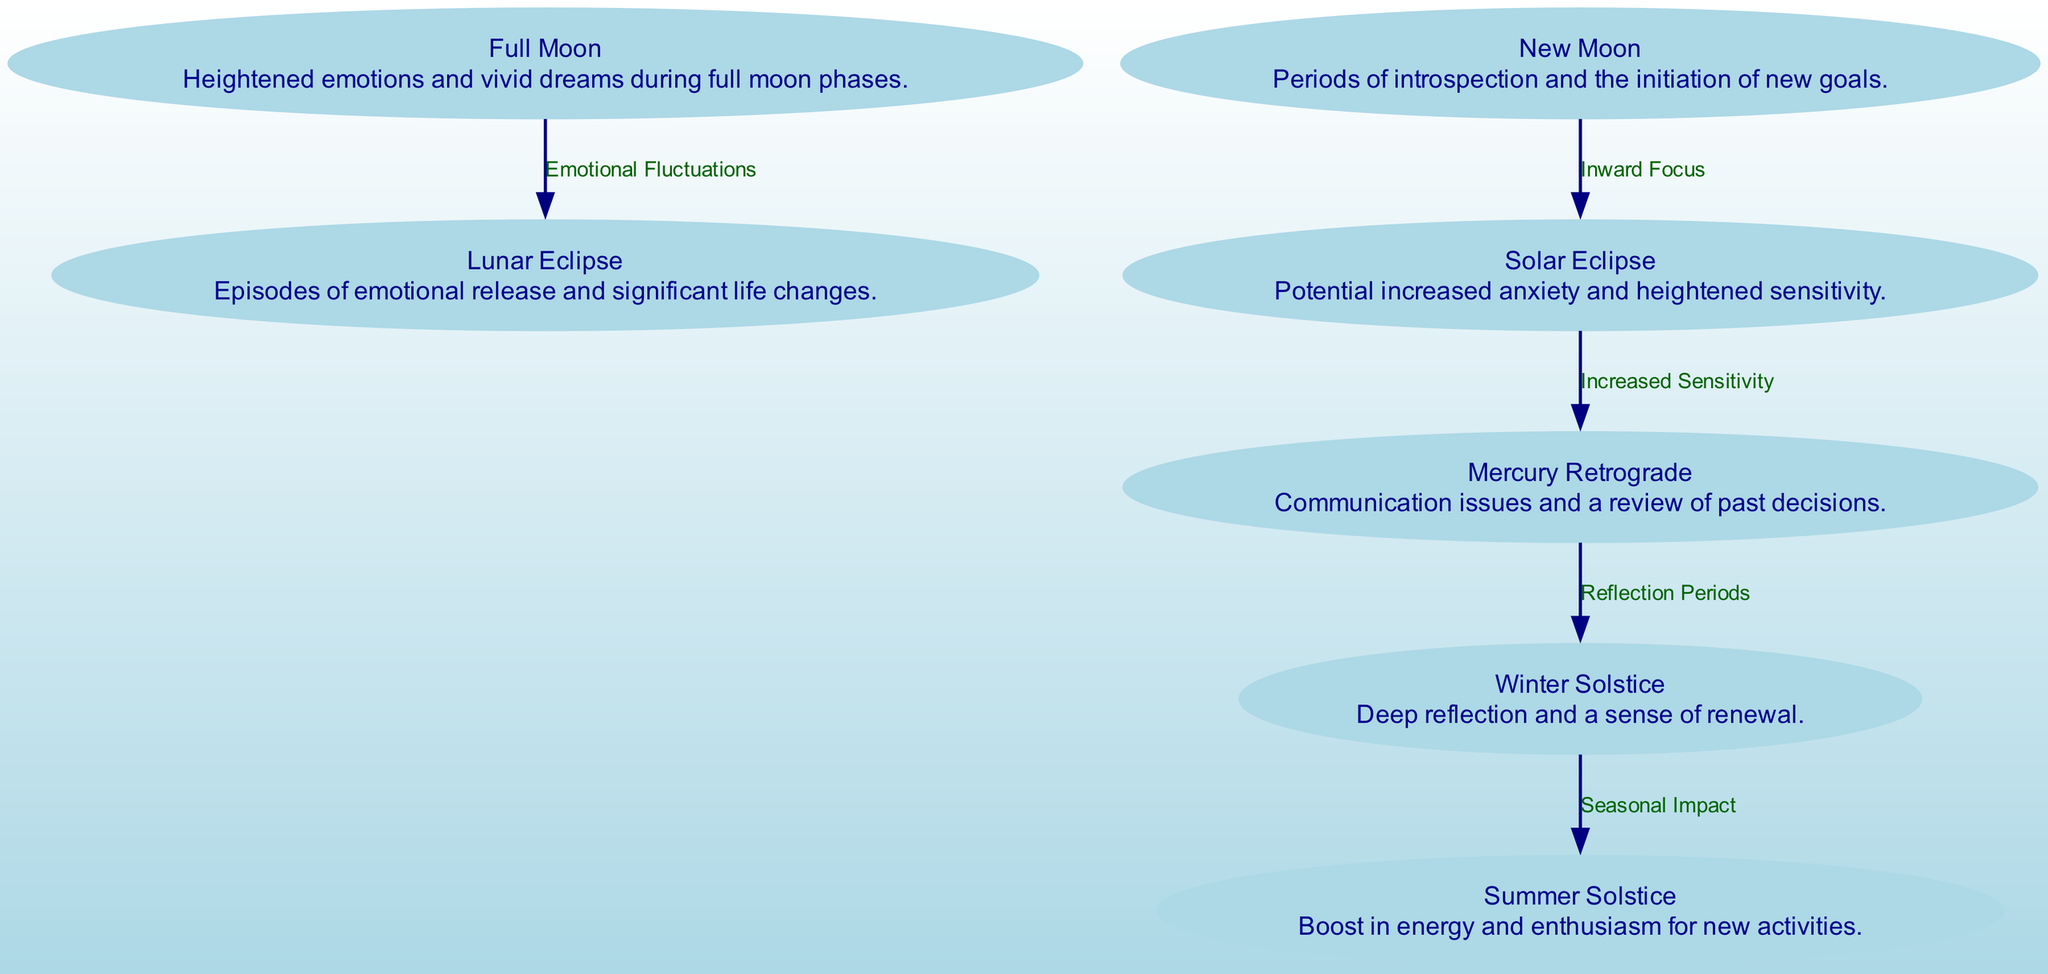What is the label of node 1? The label of node 1 is "Full Moon." This information can be found directly on the node itself in the diagram.
Answer: Full Moon How many nodes are present in the diagram? To determine the number of nodes, we can count them. There are 7 nodes, each representing a celestial event and its impact on emotions.
Answer: 7 What emotional effect is associated with the Solar Eclipse? The emotional effect associated with the Solar Eclipse is "Potential increased anxiety and heightened sensitivity." This description can be found associated with node 3.
Answer: Potential increased anxiety and heightened sensitivity Which node indicates episodes of emotional release? The node that indicates episodes of emotional release is connected to the "Lunar Eclipse." This can be identified at node 4 in the diagram.
Answer: Lunar Eclipse What are the nodes connected to the New Moon? The nodes connected to the New Moon are "Solar Eclipse." This can be seen in the edges connecting node 2 to node 3, indicating an inward focus.
Answer: Solar Eclipse What is the relationship between the Full Moon and Lunar Eclipse? The relationship between the Full Moon and Lunar Eclipse is labeled "Emotional Fluctuations." This can be observed in the edge connecting node 1 to node 4.
Answer: Emotional Fluctuations What type of emotional experience is linked to the Winter Solstice? The emotional experience linked to the Winter Solstice is "Deep reflection and a sense of renewal." This information is found at node 6.
Answer: Deep reflection and a sense of renewal How does Mercury Retrograde relate to the Winter Solstice? Mercury Retrograde leads to "Reflection Periods." This can be traced from node 5 to node 6, signifying how communication issues prompt reflection during the winter season.
Answer: Reflection Periods Which celestial event yields a boost in energy? The celestial event that yields a boost in energy is the "Summer Solstice." This is detailed in node 7.
Answer: Summer Solstice 